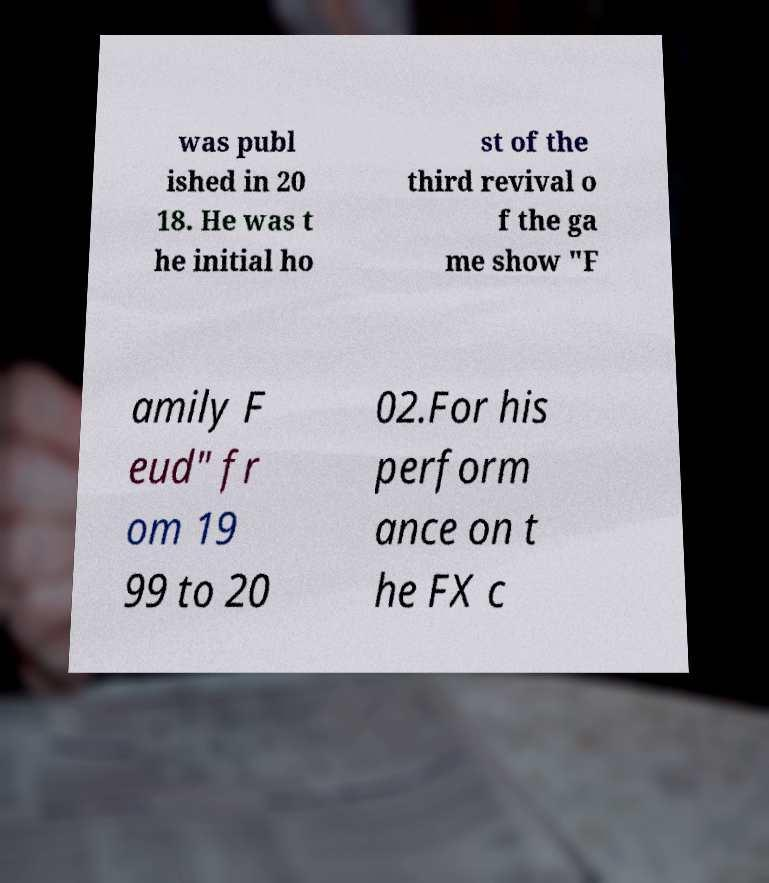Can you accurately transcribe the text from the provided image for me? was publ ished in 20 18. He was t he initial ho st of the third revival o f the ga me show "F amily F eud" fr om 19 99 to 20 02.For his perform ance on t he FX c 